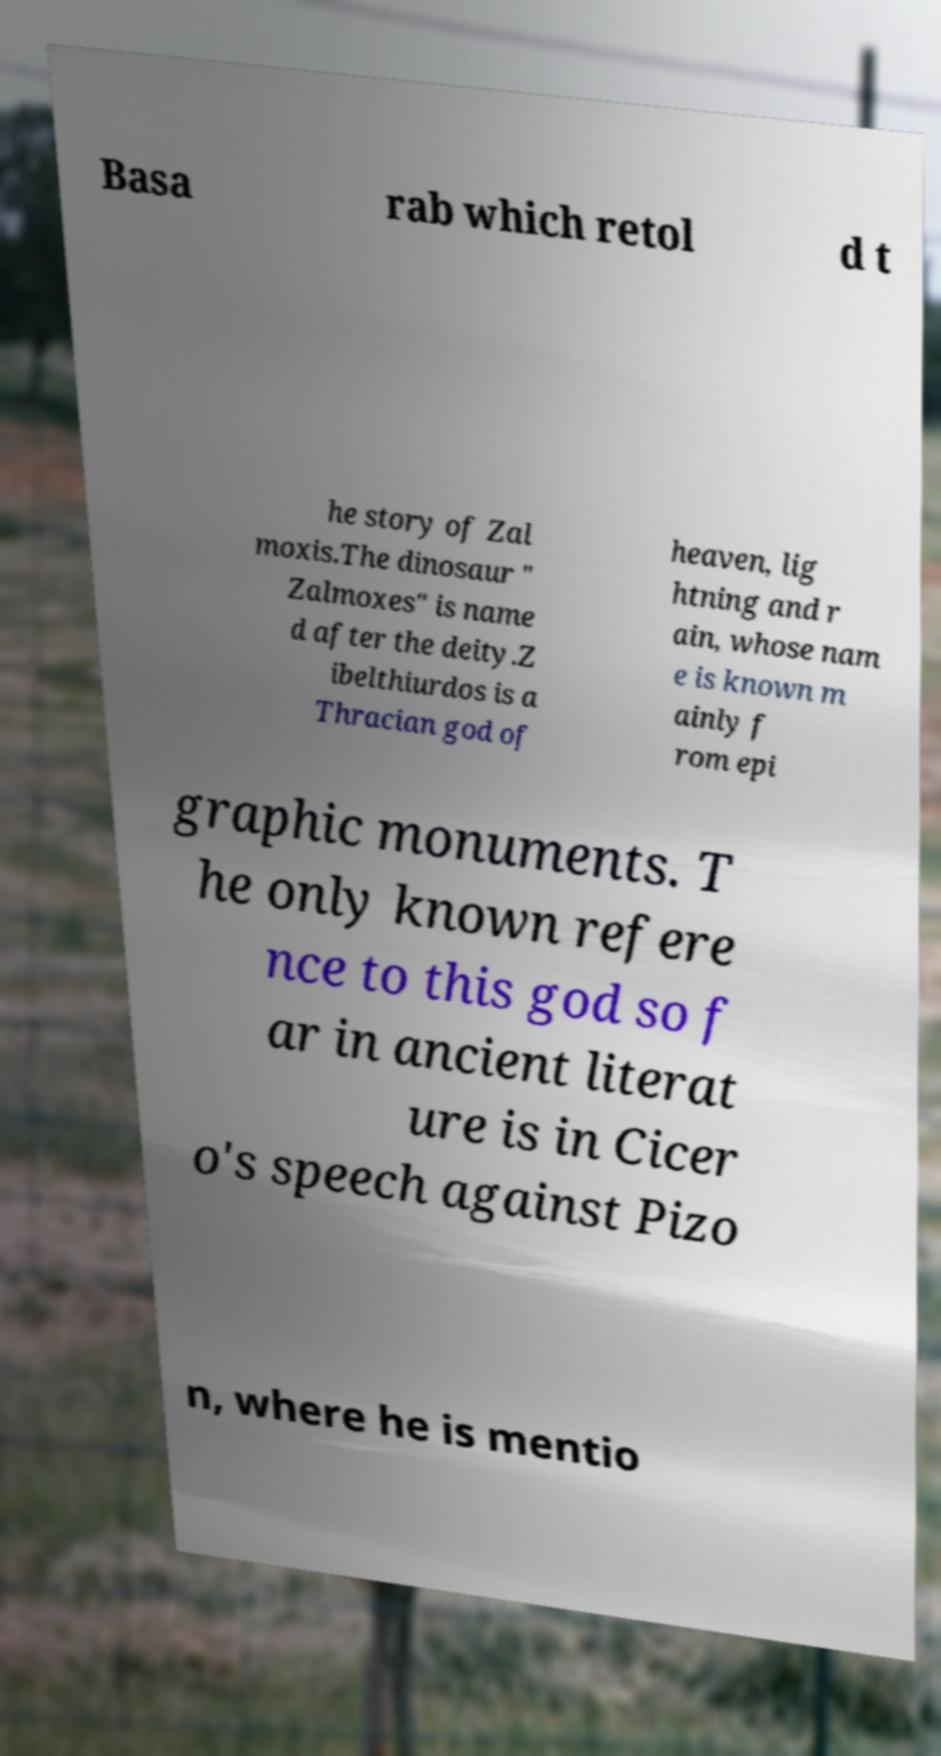For documentation purposes, I need the text within this image transcribed. Could you provide that? Basa rab which retol d t he story of Zal moxis.The dinosaur " Zalmoxes" is name d after the deity.Z ibelthiurdos is a Thracian god of heaven, lig htning and r ain, whose nam e is known m ainly f rom epi graphic monuments. T he only known refere nce to this god so f ar in ancient literat ure is in Cicer o's speech against Pizo n, where he is mentio 